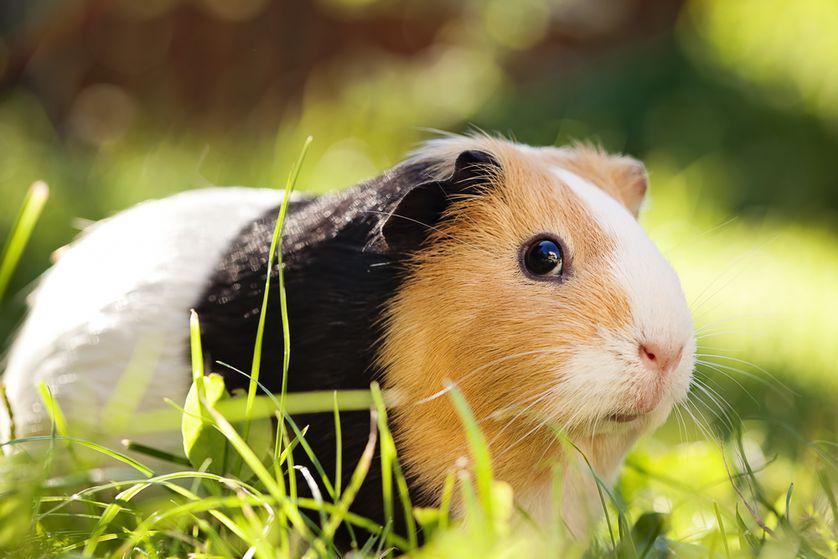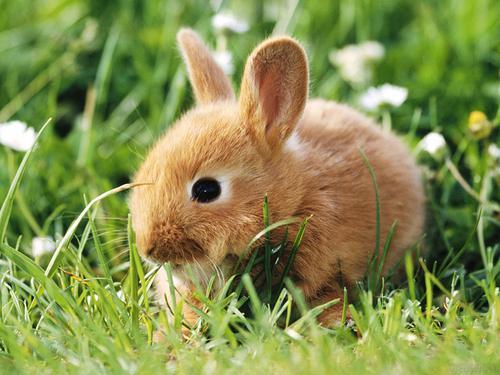The first image is the image on the left, the second image is the image on the right. Examine the images to the left and right. Is the description "Each image contains the same number of guinea pigs, and all animals share similar poses." accurate? Answer yes or no. No. 